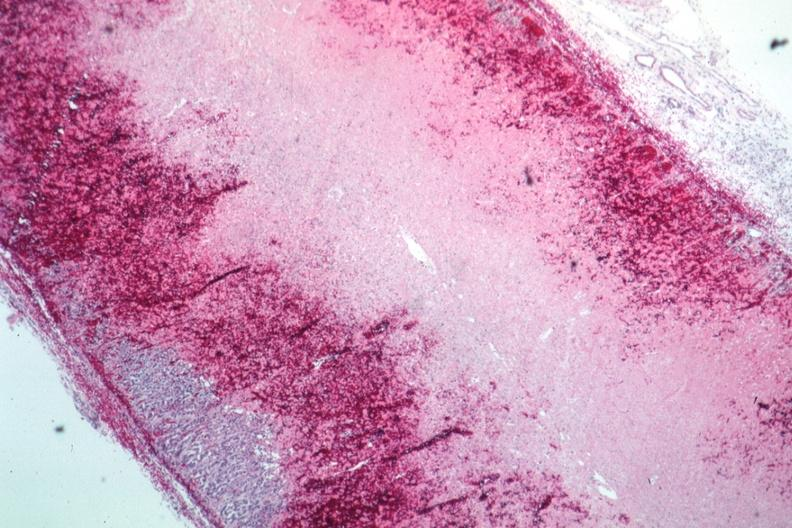s carcinoma present?
Answer the question using a single word or phrase. No 